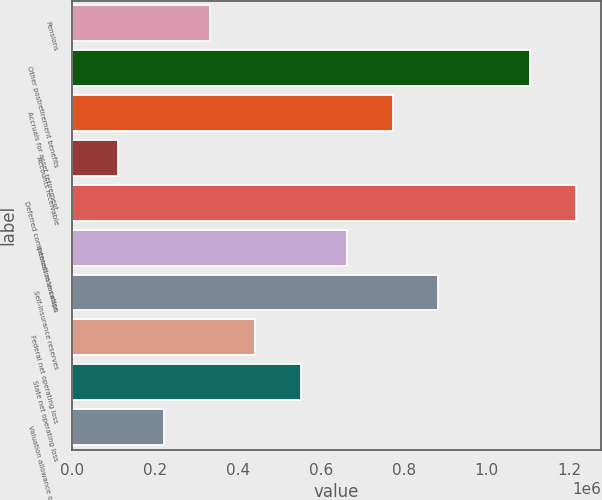Convert chart to OTSL. <chart><loc_0><loc_0><loc_500><loc_500><bar_chart><fcel>Pensions<fcel>Other postretirement benefits<fcel>Accruals for asset retirement<fcel>Accounts receivable<fcel>Deferred compensation vacation<fcel>Interest rate swaps<fcel>Self-insurance reserves<fcel>Federal net operating loss<fcel>State net operating loss<fcel>Valuation allowance on state<nl><fcel>332616<fcel>1.1046e+06<fcel>773748<fcel>112051<fcel>1.21488e+06<fcel>663465<fcel>884030<fcel>442899<fcel>553182<fcel>222334<nl></chart> 